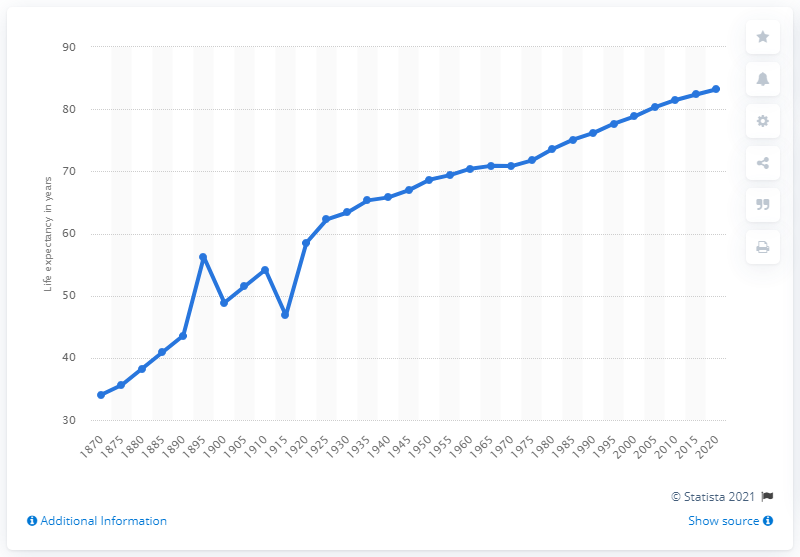List a handful of essential elements in this visual. The expected increase in life expectancy in Australia by 2020 is 83.2 years. In 1870, the life expectancy of Australians was just below 35 years old. 